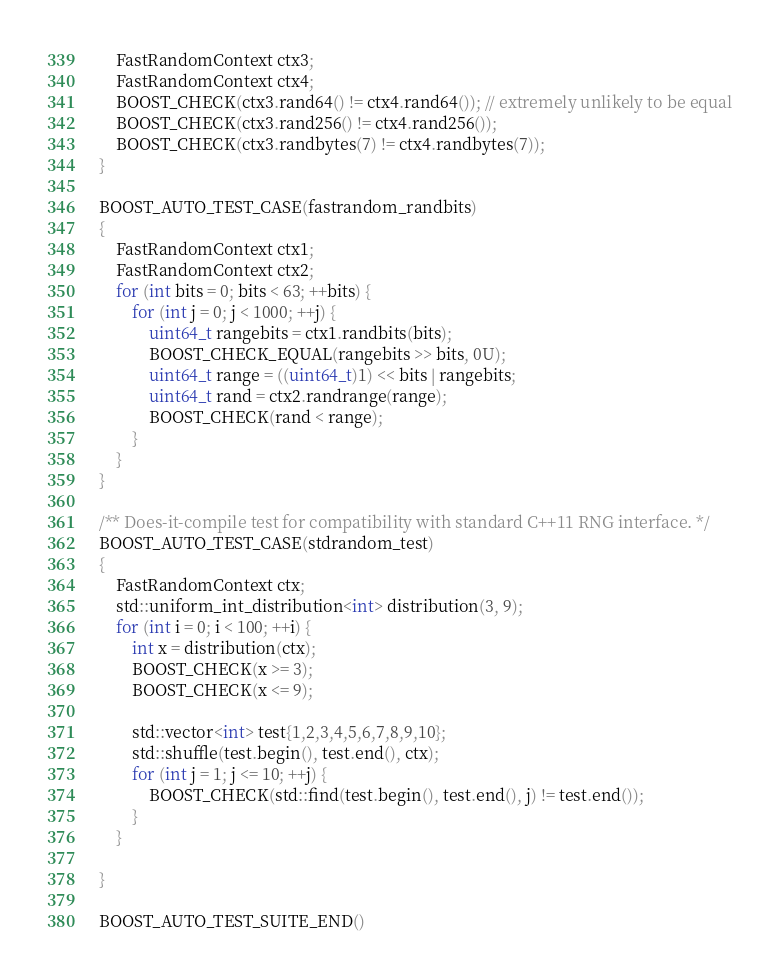<code> <loc_0><loc_0><loc_500><loc_500><_C++_>    FastRandomContext ctx3;
    FastRandomContext ctx4;
    BOOST_CHECK(ctx3.rand64() != ctx4.rand64()); // extremely unlikely to be equal
    BOOST_CHECK(ctx3.rand256() != ctx4.rand256());
    BOOST_CHECK(ctx3.randbytes(7) != ctx4.randbytes(7));
}

BOOST_AUTO_TEST_CASE(fastrandom_randbits)
{
    FastRandomContext ctx1;
    FastRandomContext ctx2;
    for (int bits = 0; bits < 63; ++bits) {
        for (int j = 0; j < 1000; ++j) {
            uint64_t rangebits = ctx1.randbits(bits);
            BOOST_CHECK_EQUAL(rangebits >> bits, 0U);
            uint64_t range = ((uint64_t)1) << bits | rangebits;
            uint64_t rand = ctx2.randrange(range);
            BOOST_CHECK(rand < range);
        }
    }
}

/** Does-it-compile test for compatibility with standard C++11 RNG interface. */
BOOST_AUTO_TEST_CASE(stdrandom_test)
{
    FastRandomContext ctx;
    std::uniform_int_distribution<int> distribution(3, 9);
    for (int i = 0; i < 100; ++i) {
        int x = distribution(ctx);
        BOOST_CHECK(x >= 3);
        BOOST_CHECK(x <= 9);

        std::vector<int> test{1,2,3,4,5,6,7,8,9,10};
        std::shuffle(test.begin(), test.end(), ctx);
        for (int j = 1; j <= 10; ++j) {
            BOOST_CHECK(std::find(test.begin(), test.end(), j) != test.end());
        }
    }

}

BOOST_AUTO_TEST_SUITE_END()
</code> 